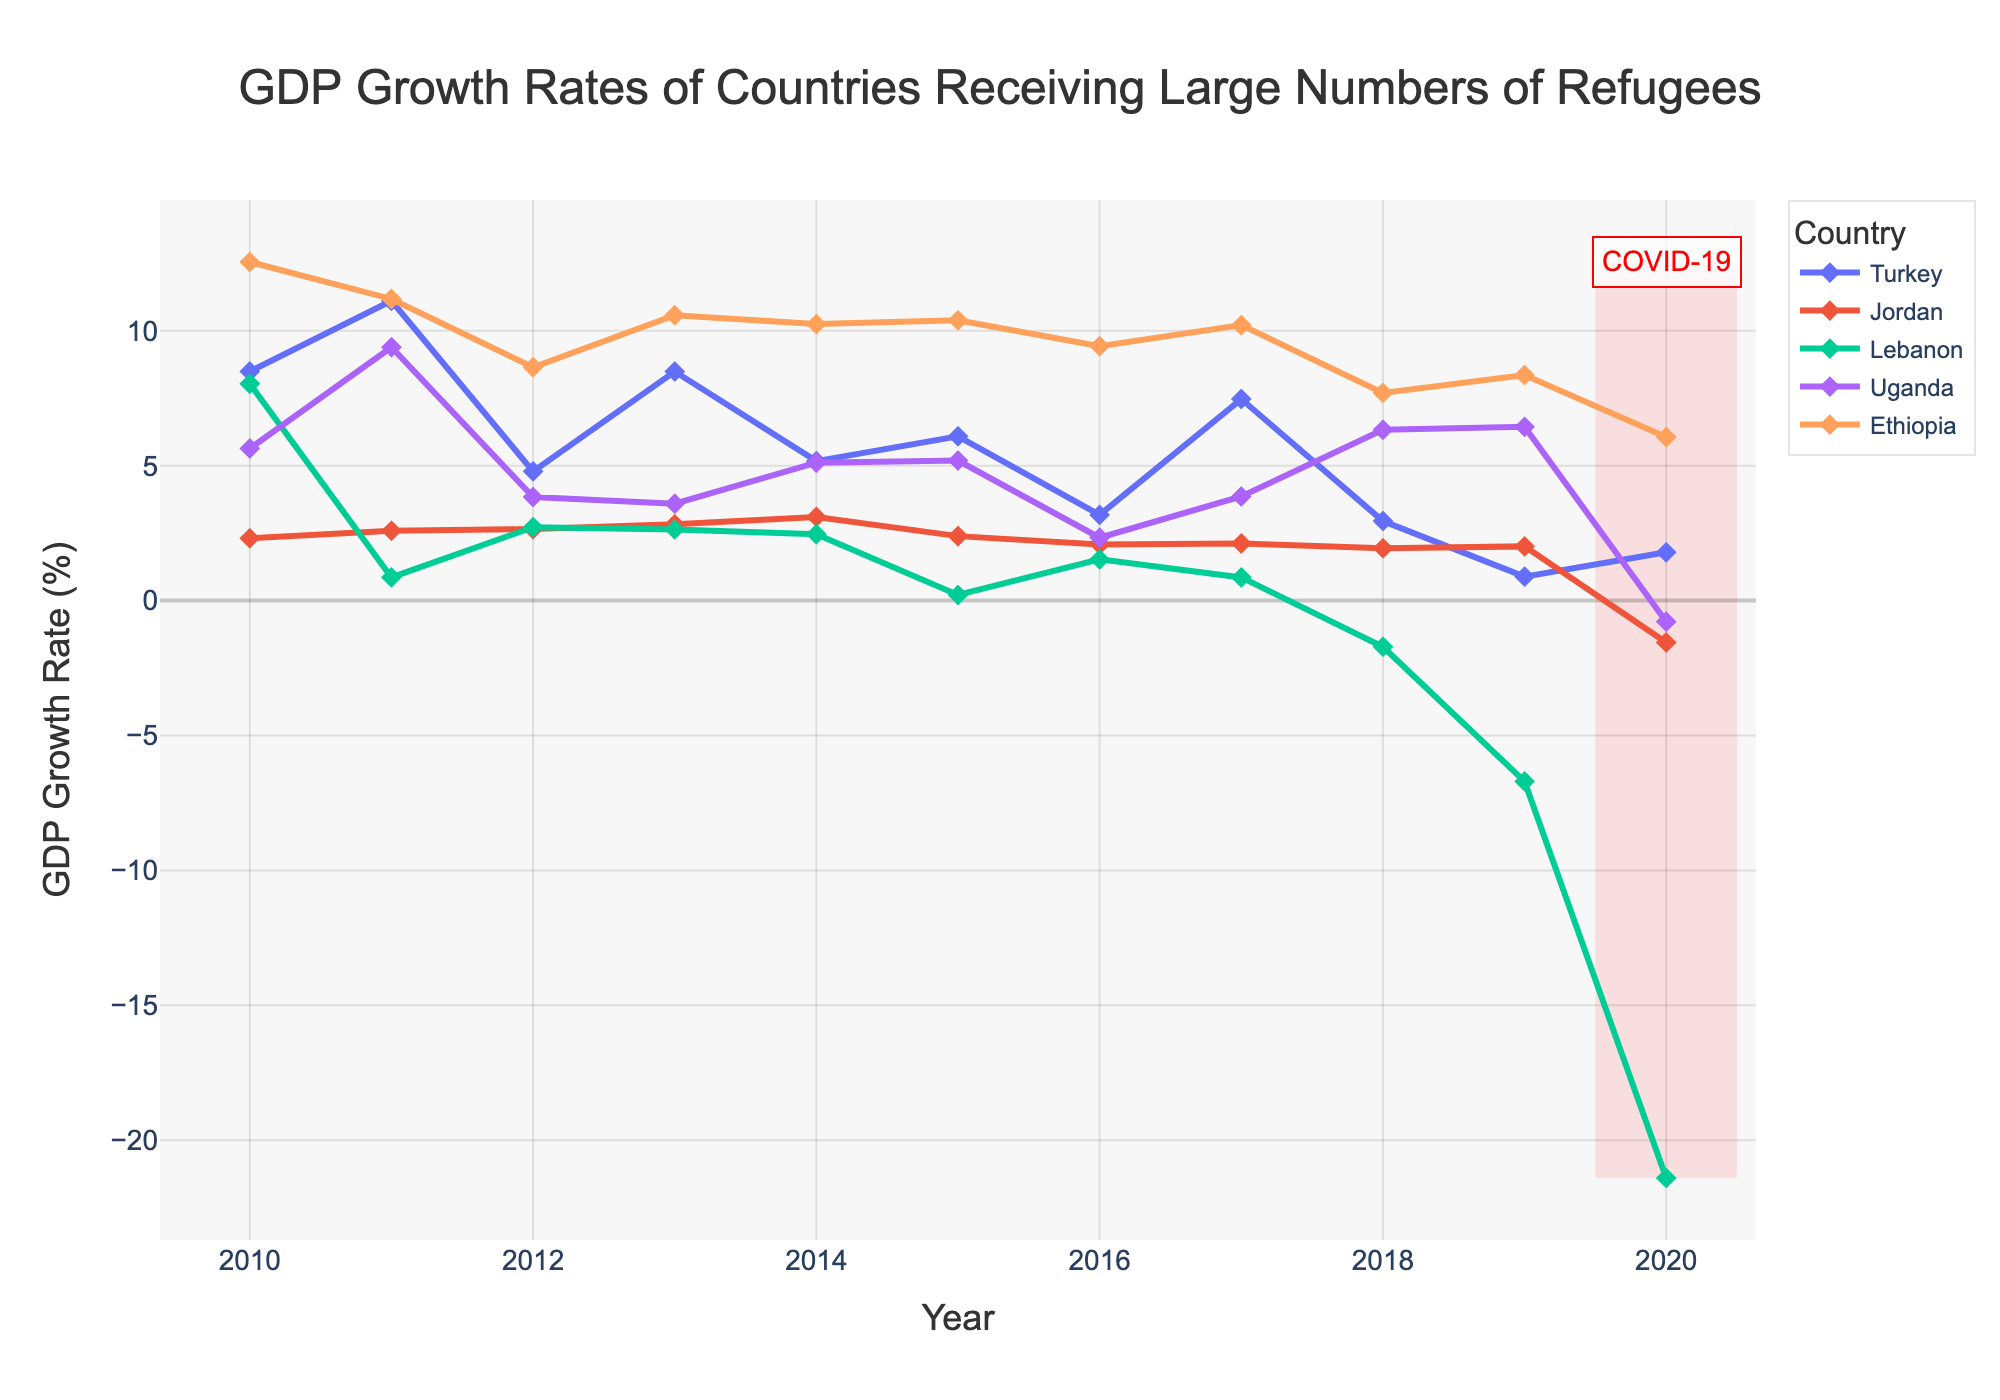What's the general trend of Turkey's GDP growth rate from 2010 to 2020? The general trend shows fluctuating growth rates with high peaks in 2010 and 2011, a significant dip in 2019, and a slight recovery in 2020.
Answer: Fluctuating Which country experienced the largest negative GDP growth rate in 2020? By inspecting the values at the year 2020 across all countries, Lebanon shows the most substantial negative GDP growth rate in 2020.
Answer: Lebanon Compare the GDP growth rate trends of Uganda and Ethiopia from 2010 to 2020. Which country had more stable growth? Observing the line plots for Uganda and Ethiopia, Ethiopia had consistently high growth rates, whereas Uganda's growth rates showed more variability. Hence, Ethiopia had more stable growth.
Answer: Ethiopia Which country had the highest GDP growth rate in 2019? By comparing the data points for the year 2019, Ethiopia displayed the highest GDP growth rate in 2019.
Answer: Ethiopia How did the COVID-19 pandemic in 2020 affect the GDP growth rates of the displayed countries? All countries experienced a notable decline in GDP growth rates during 2020, highlighted by the red rectangle. Each country's GDP either dropped sharply or went negative around this period.
Answer: Decline From the available data, which country saw the most dramatic decline in GDP growth from any year to the following year? By examining the difference in GDP growth rates year-over-year, Lebanon experienced the most dramatic decline from 2019 to 2020.
Answer: Lebanon Comparing Jordan and Lebanon, which country had a higher average GDP growth rate over the entire period? Sum the annual GDP growth rates for Jordan and Lebanon from 2010 to 2020, and then divide by 11 years. Jordan's total (22.67) divided by 10 years is higher than Lebanon's total (8.91) divided by 10 years.
Answer: Jordan Which two countries showed primarily positive GDP growth rates throughout most of the given period? Turkey and Ethiopia showed primarily positive growth rates throughout most of the period from 2010 to 2020, compared to the other countries.
Answer: Turkey and Ethiopia What can be inferred about the economic stability of Lebanon by observing its GDP growth rates from 2010 to 2020? Lebanon starts with high growth in early years but shows significant fluctuations and extreme negative values towards the end, especially in 2019 and 2020, indicating economic instability.
Answer: Economic instability During which year did Turkey experience the maximum GDP growth rate, and what was the value? By observing Turkey's line plot, the maximum GDP growth rate occurred in 2011 with a value of 11.11%.
Answer: 2011, 11.11% 